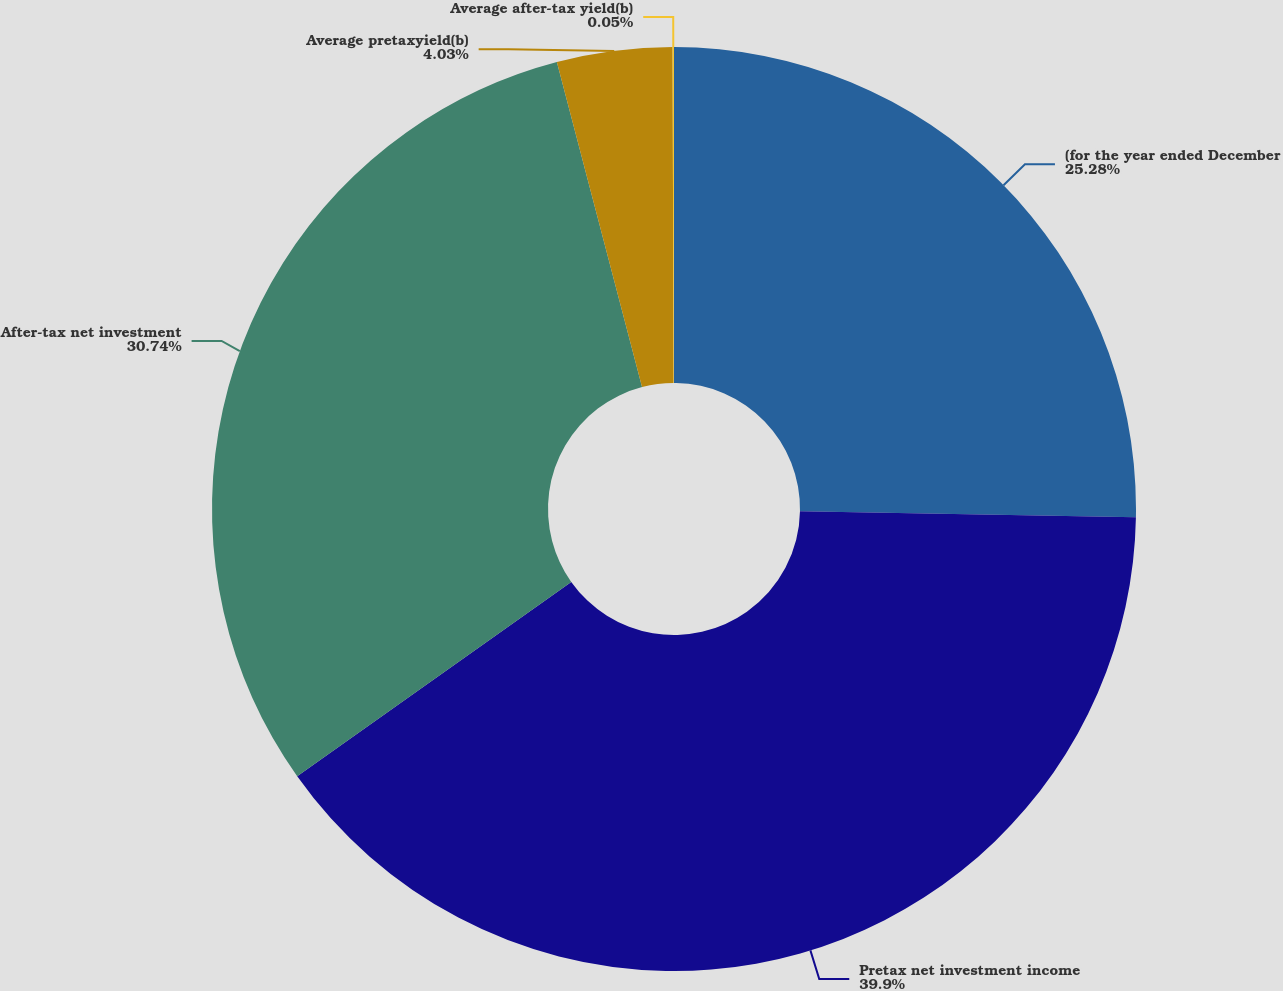<chart> <loc_0><loc_0><loc_500><loc_500><pie_chart><fcel>(for the year ended December<fcel>Pretax net investment income<fcel>After-tax net investment<fcel>Average pretaxyield(b)<fcel>Average after-tax yield(b)<nl><fcel>25.28%<fcel>39.9%<fcel>30.74%<fcel>4.03%<fcel>0.05%<nl></chart> 